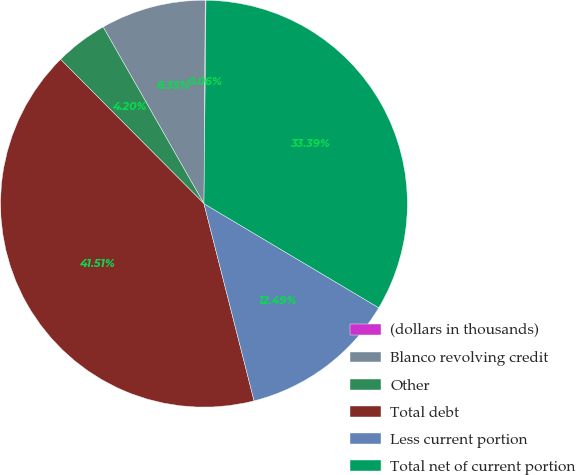Convert chart. <chart><loc_0><loc_0><loc_500><loc_500><pie_chart><fcel>(dollars in thousands)<fcel>Blanco revolving credit<fcel>Other<fcel>Total debt<fcel>Less current portion<fcel>Total net of current portion<nl><fcel>0.06%<fcel>8.35%<fcel>4.2%<fcel>41.51%<fcel>12.49%<fcel>33.39%<nl></chart> 